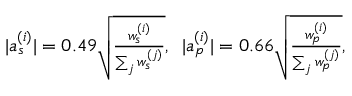<formula> <loc_0><loc_0><loc_500><loc_500>\begin{array} { r } { | a _ { s } ^ { ( i ) } | = 0 . 4 9 \sqrt { \frac { w _ { s } ^ { ( i ) } } { \sum _ { j } w _ { s } ^ { ( j ) } } } , \, | a _ { p } ^ { ( i ) } | = 0 . 6 6 \sqrt { \frac { w _ { p } ^ { ( i ) } } { \sum _ { j } w _ { p } ^ { ( j ) } } } , } \end{array}</formula> 